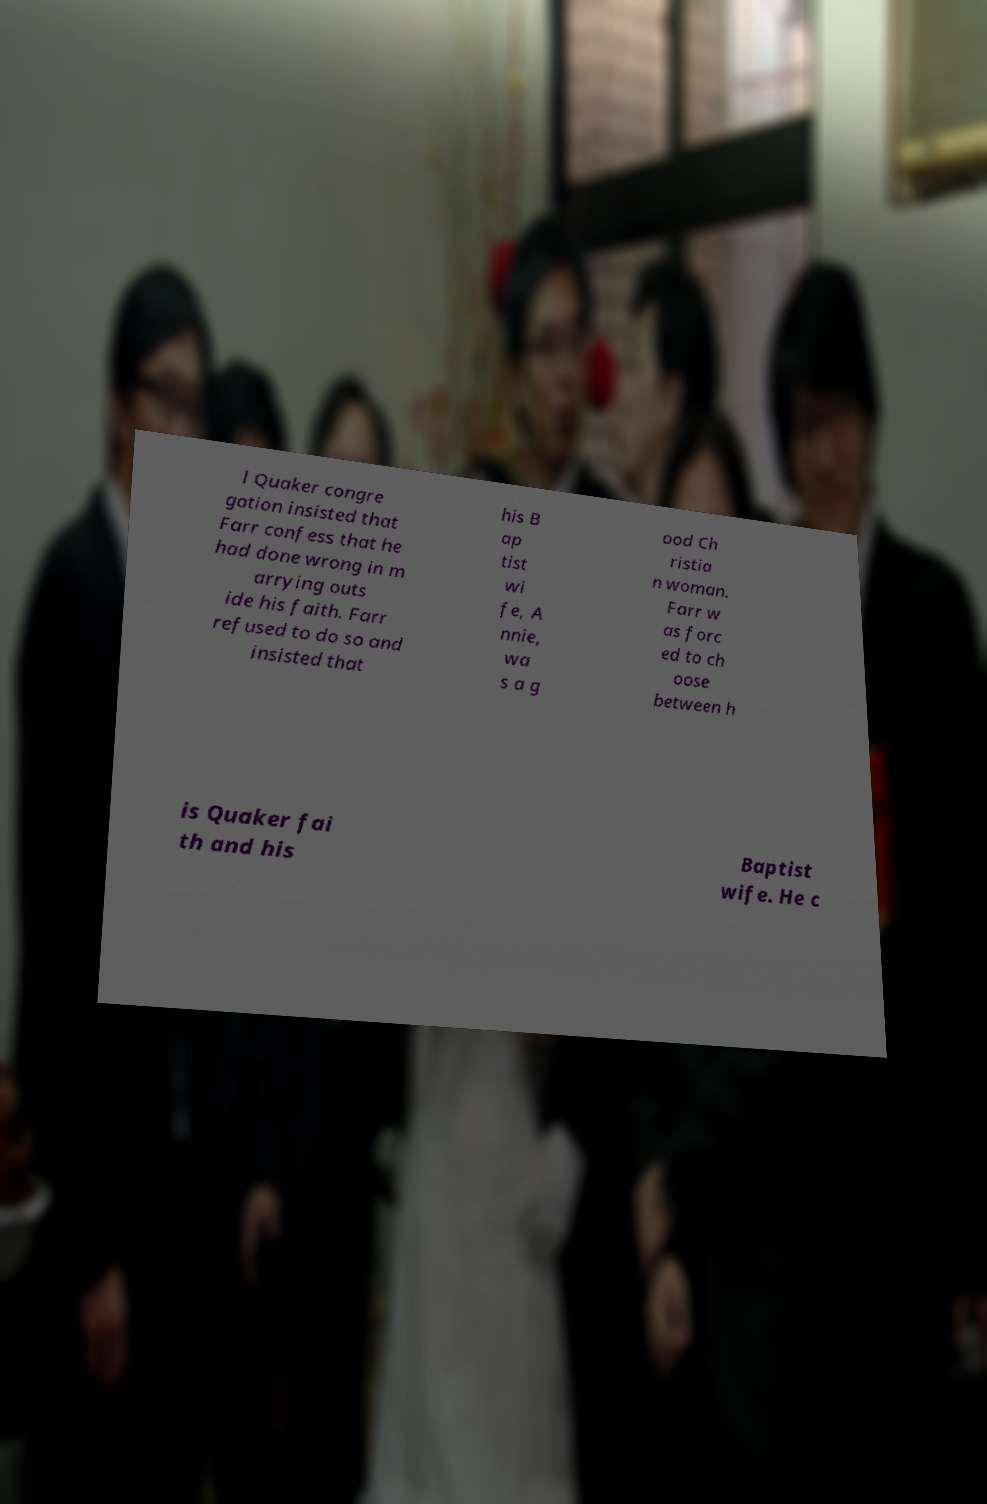Please identify and transcribe the text found in this image. l Quaker congre gation insisted that Farr confess that he had done wrong in m arrying outs ide his faith. Farr refused to do so and insisted that his B ap tist wi fe, A nnie, wa s a g ood Ch ristia n woman. Farr w as forc ed to ch oose between h is Quaker fai th and his Baptist wife. He c 